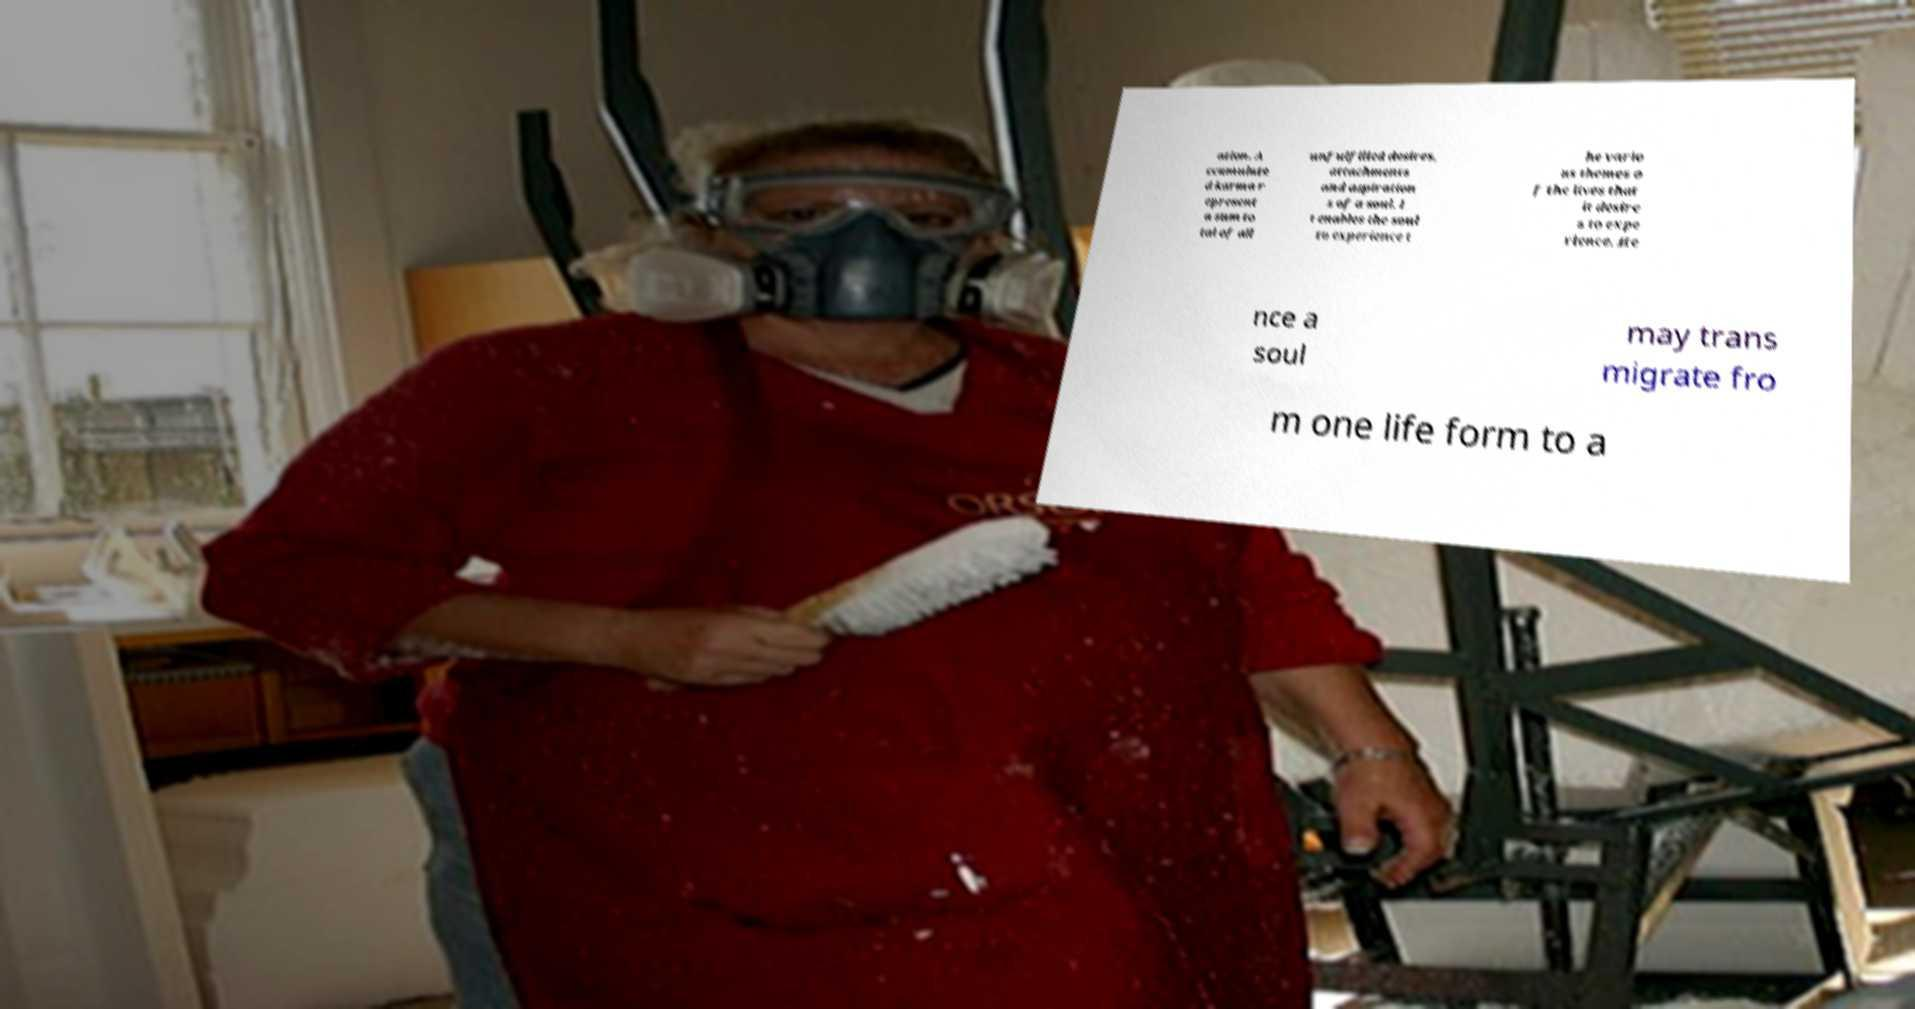What messages or text are displayed in this image? I need them in a readable, typed format. ation. A ccumulate d karma r epresent a sum to tal of all unfulfilled desires, attachments and aspiration s of a soul. I t enables the soul to experience t he vario us themes o f the lives that it desire s to expe rience. He nce a soul may trans migrate fro m one life form to a 